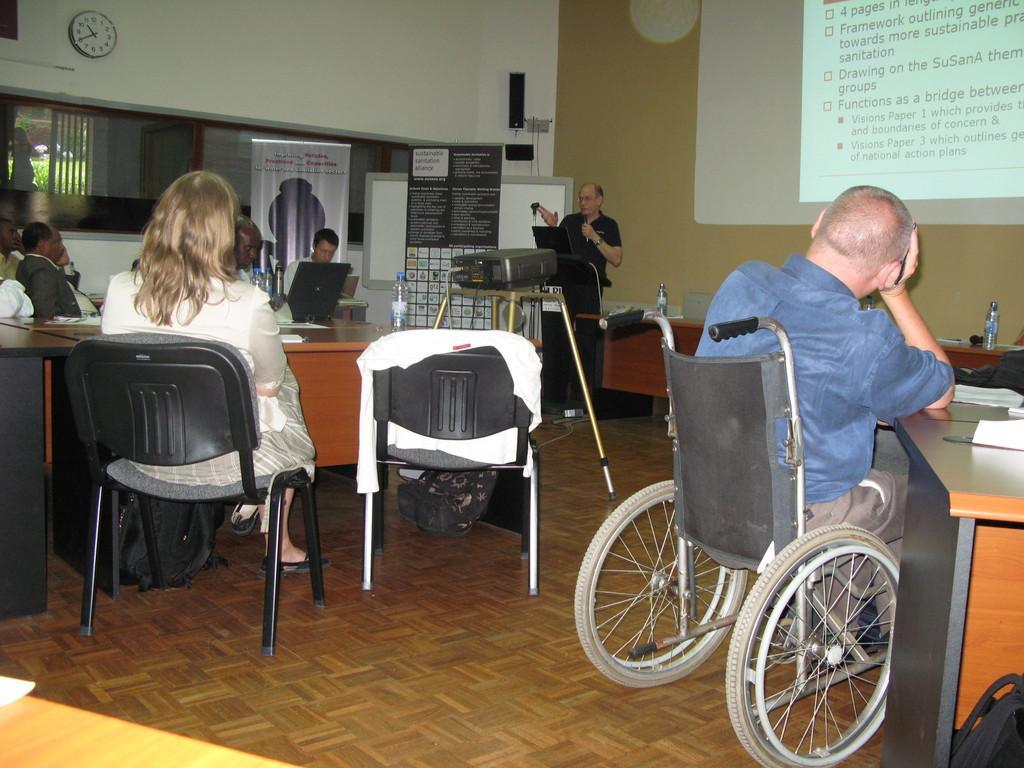Please provide a concise description of this image. Image group of people sitting,the man is sitting in the wheel chair, at the back ground i can see a man standing, a projector,a banner and a wall and a clock. 